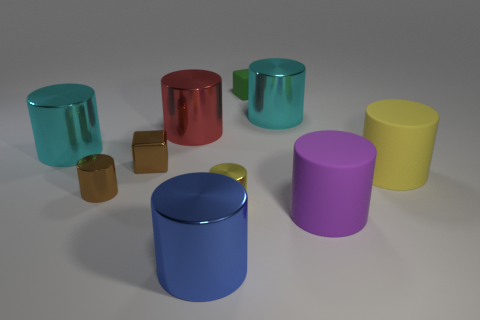How would you describe the arrangement of the objects in relation to each other? The objects are placed in an intentionally scattered arrangement, suggesting a casual or random distribution within the space. The placement creates a visual flow that guides the eye across the various colors and sizes, emphasizing the diversity of objects present. 